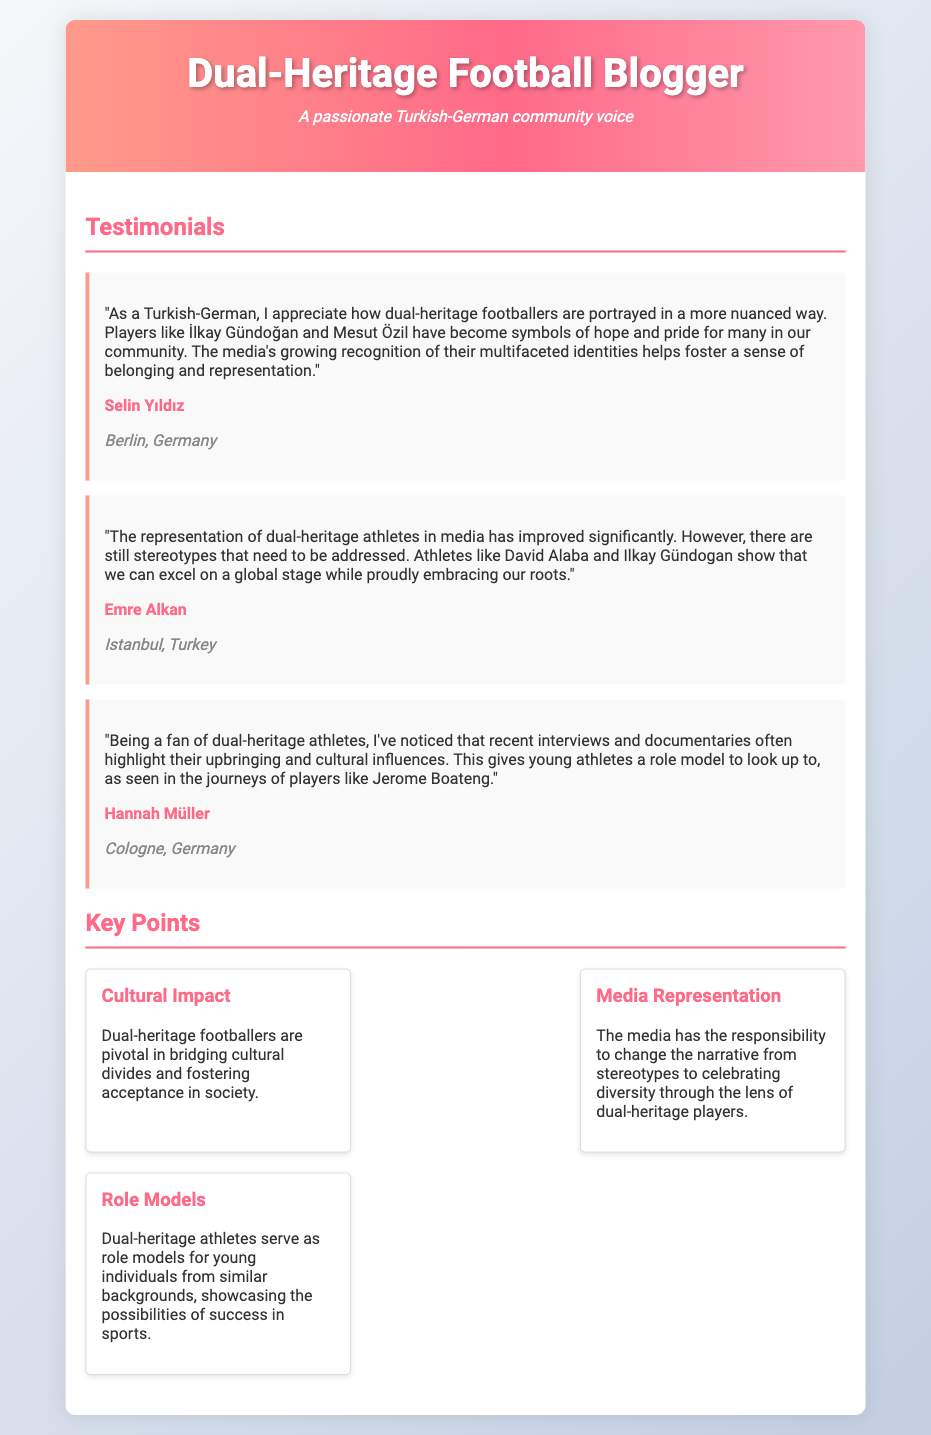What is the name of the Turkish-German blogger? The name of the blogger is presented in the header section of the document.
Answer: Dual-Heritage Football Blogger What is the subtitle of the blog? The subtitle indicates the community focus of the blogger.
Answer: A passionate Turkish-German community voice Who is the first testimonial from? The document lists individuals who provided feedback in the testimonials section.
Answer: Selin Yıldız Which athlete is mentioned as a symbol of hope in the first testimonial? The first testimonial highlights a specific footballer associated with the speaker’s community.
Answer: İlkay Gündoğan What does the second testimonial mention about David Alaba? The second testimonial points out the positive perception and achievements of dual-heritage athletes.
Answer: Shows that we can excel on a global stage while proudly embracing our roots Which city is Hannah Müller from? This information can be found in the location section of her testimonial.
Answer: Cologne, Germany What cultural factor do dual-heritage footballers bridge according to the key points? This information is covered in the cultural impact section of the key points.
Answer: Cultural divides What responsibility does the media have according to the media representation key point? This refers to the role of media in shaping representations of dual-heritage athletes.
Answer: Change the narrative from stereotypes to celebrating diversity How many key points are listed in the document? The number of key points can be counted in the key points section.
Answer: Three 